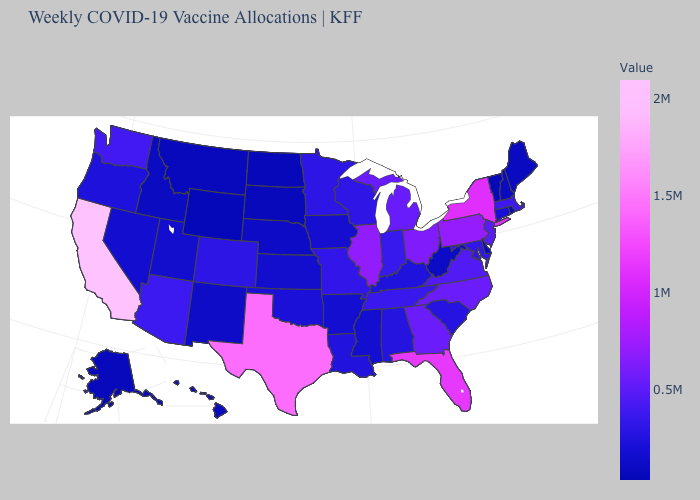Does Washington have a lower value than Texas?
Be succinct. Yes. Which states have the highest value in the USA?
Keep it brief. California. Which states have the highest value in the USA?
Keep it brief. California. Among the states that border Nebraska , does Missouri have the highest value?
Write a very short answer. Yes. 